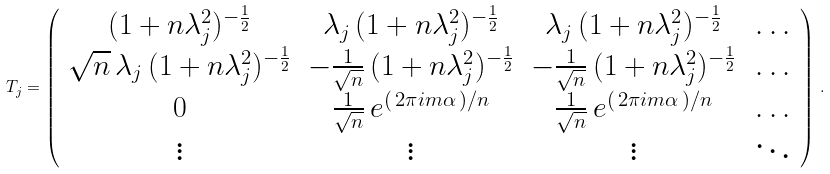<formula> <loc_0><loc_0><loc_500><loc_500>T _ { j } = \left ( \begin{array} { c c c c } ( 1 + n \lambda _ { j } ^ { 2 } ) ^ { - \frac { 1 } { 2 } } & \lambda _ { j } \, ( 1 + n \lambda _ { j } ^ { 2 } ) ^ { - \frac { 1 } { 2 } } & \lambda _ { j } \, ( 1 + n \lambda _ { j } ^ { 2 } ) ^ { - \frac { 1 } { 2 } } & \dots \\ \sqrt { n } \, \lambda _ { j } \, ( 1 + n \lambda _ { j } ^ { 2 } ) ^ { - \frac { 1 } { 2 } } & - \frac { 1 } { \sqrt { n } } \, ( 1 + n \lambda _ { j } ^ { 2 } ) ^ { - \frac { 1 } { 2 } } & - \frac { 1 } { \sqrt { n } } \, ( 1 + n \lambda _ { j } ^ { 2 } ) ^ { - \frac { 1 } { 2 } } & \dots \\ 0 & \frac { 1 } { \sqrt { n } } \, e ^ { ( \, 2 \pi i m \alpha \, ) / n } & \frac { 1 } { \sqrt { n } } \, e ^ { ( \, 2 \pi i m \alpha \, ) / n } & \dots \\ \vdots & \vdots & \vdots & \ddots \end{array} \right ) \, .</formula> 